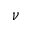<formula> <loc_0><loc_0><loc_500><loc_500>\nu</formula> 